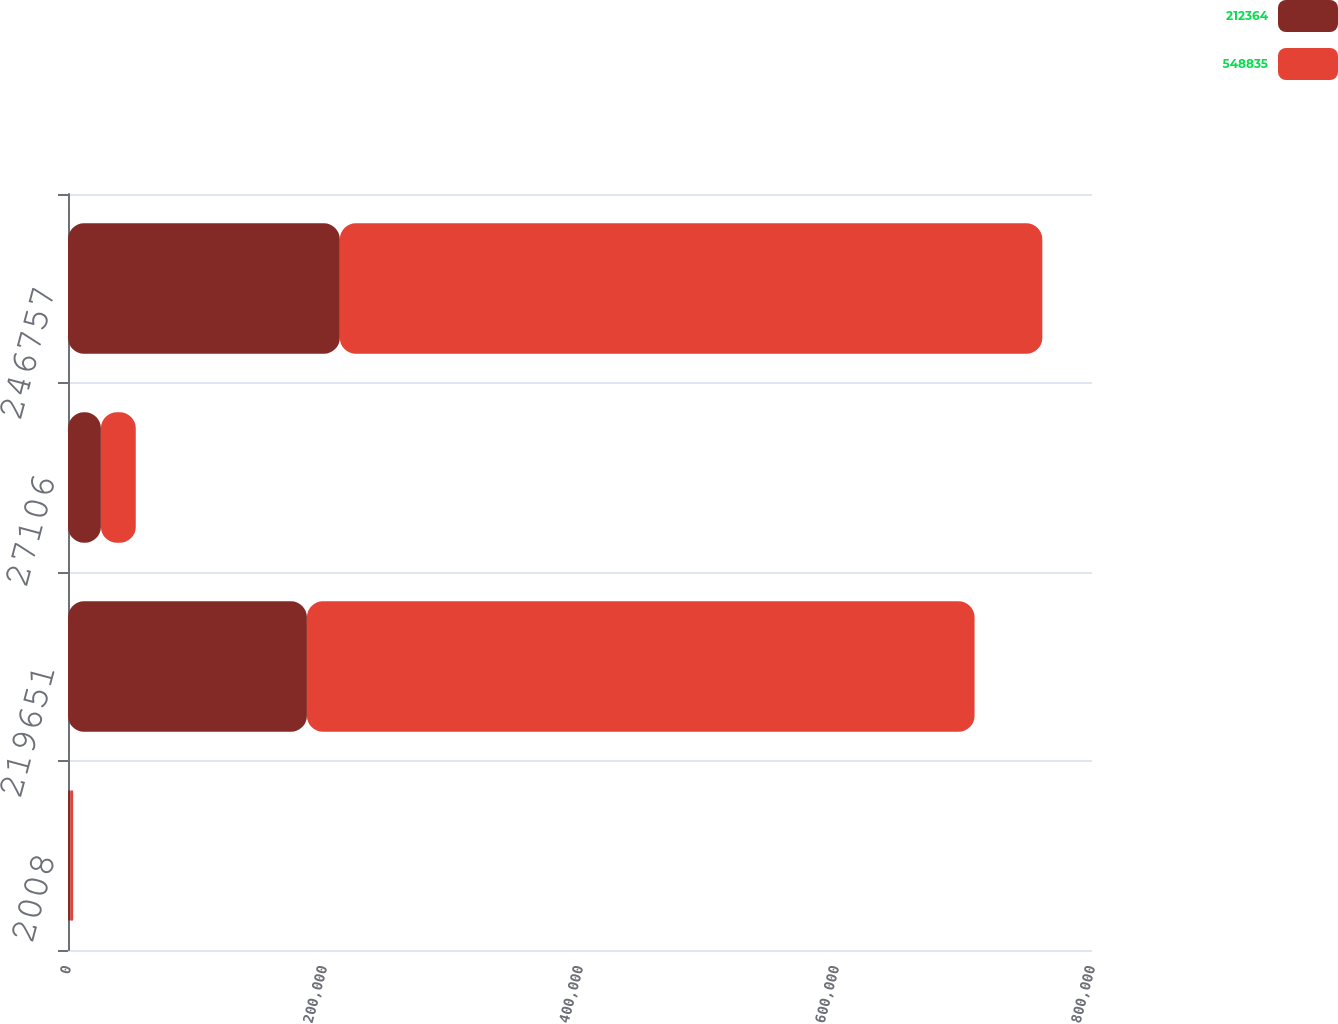<chart> <loc_0><loc_0><loc_500><loc_500><stacked_bar_chart><ecel><fcel>2008<fcel>219651<fcel>27106<fcel>246757<nl><fcel>212364<fcel>2007<fcel>186654<fcel>25710<fcel>212364<nl><fcel>548835<fcel>2006<fcel>521615<fcel>27220<fcel>548835<nl></chart> 